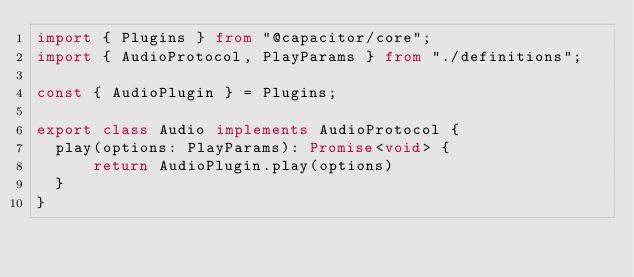<code> <loc_0><loc_0><loc_500><loc_500><_TypeScript_>import { Plugins } from "@capacitor/core";
import { AudioProtocol, PlayParams } from "./definitions";

const { AudioPlugin } = Plugins;

export class Audio implements AudioProtocol {
  play(options: PlayParams): Promise<void> {
      return AudioPlugin.play(options)
  }
}</code> 